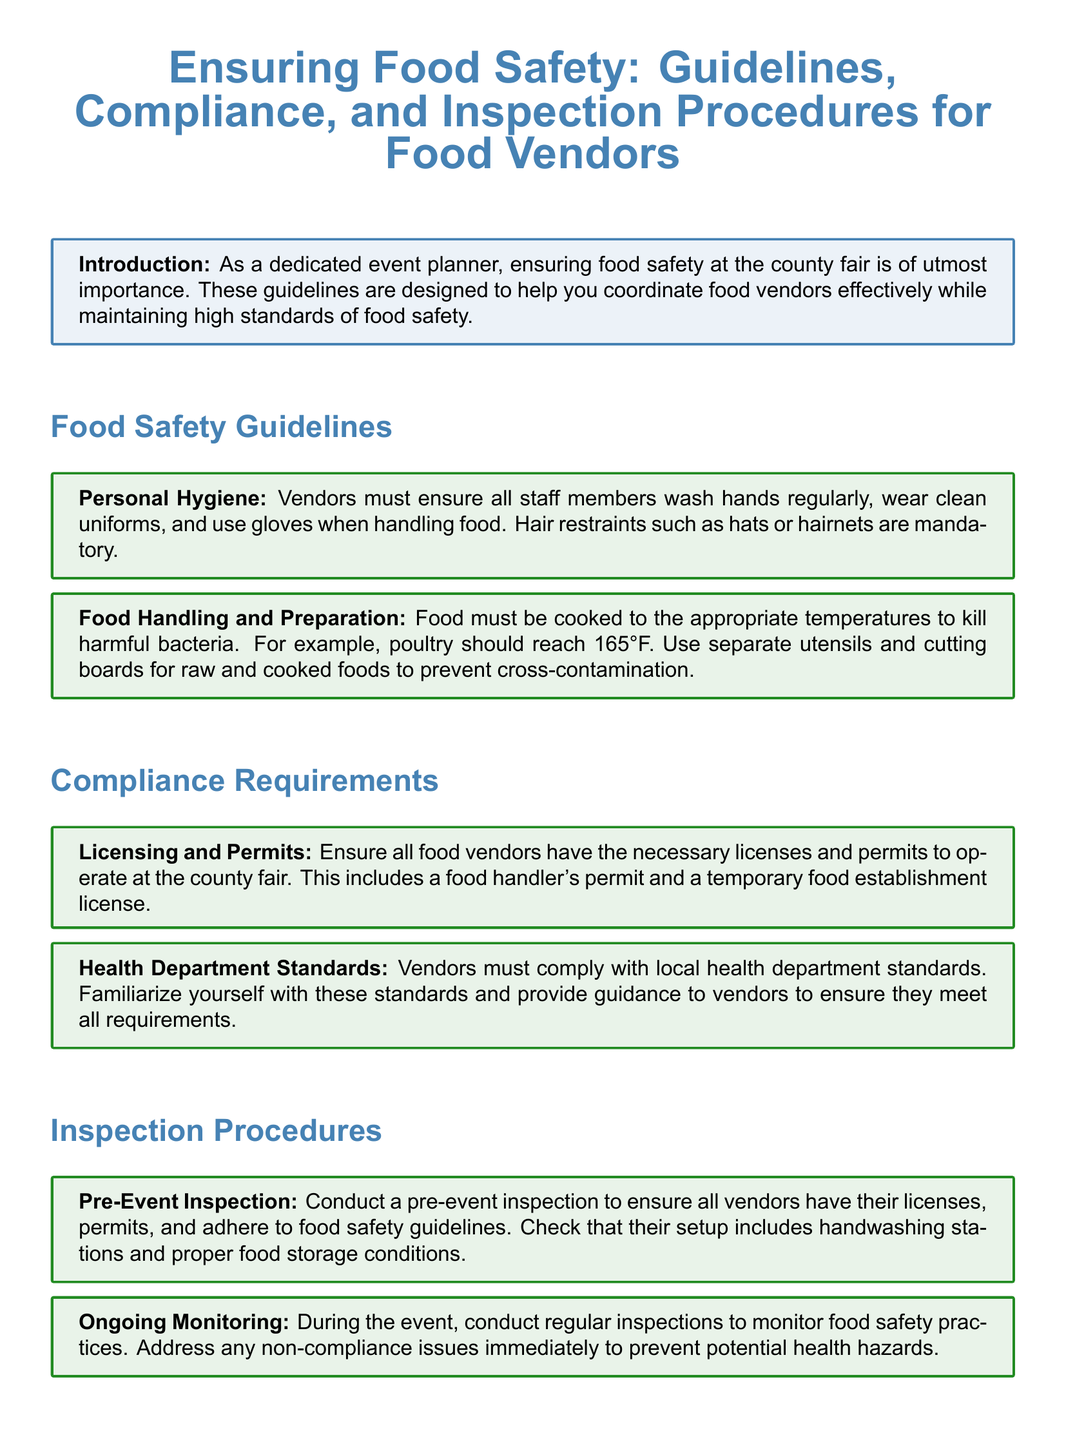What must vendors ensure regarding personal hygiene? The document specifies that vendors must ensure all staff members wash hands regularly, wear clean uniforms, and use gloves when handling food.
Answer: Clean uniforms What temperature should poultry be cooked to? The guideline states poultry should reach 165°F to kill harmful bacteria.
Answer: 165°F What kind of licenses are required for food vendors? Vendors are required to have a food handler's permit and a temporary food establishment license to operate at the county fair.
Answer: Food handler's permit and temporary food establishment license What must be checked during a pre-event inspection? During a pre-event inspection, it is essential to check that all vendors have their licenses, permits, and adhere to food safety guidelines, including setup with handwashing stations and proper food storage.
Answer: Licenses and permits What should be done during ongoing monitoring? The document states that during the event, regular inspections should be conducted to monitor food safety practices and address any non-compliance issues immediately.
Answer: Regular inspections What is the impact of following the guidelines? Following the guidelines helps ensure that food vendors maintain high standards of food safety, providing a safe experience for attendees.
Answer: Safe experience for attendees 